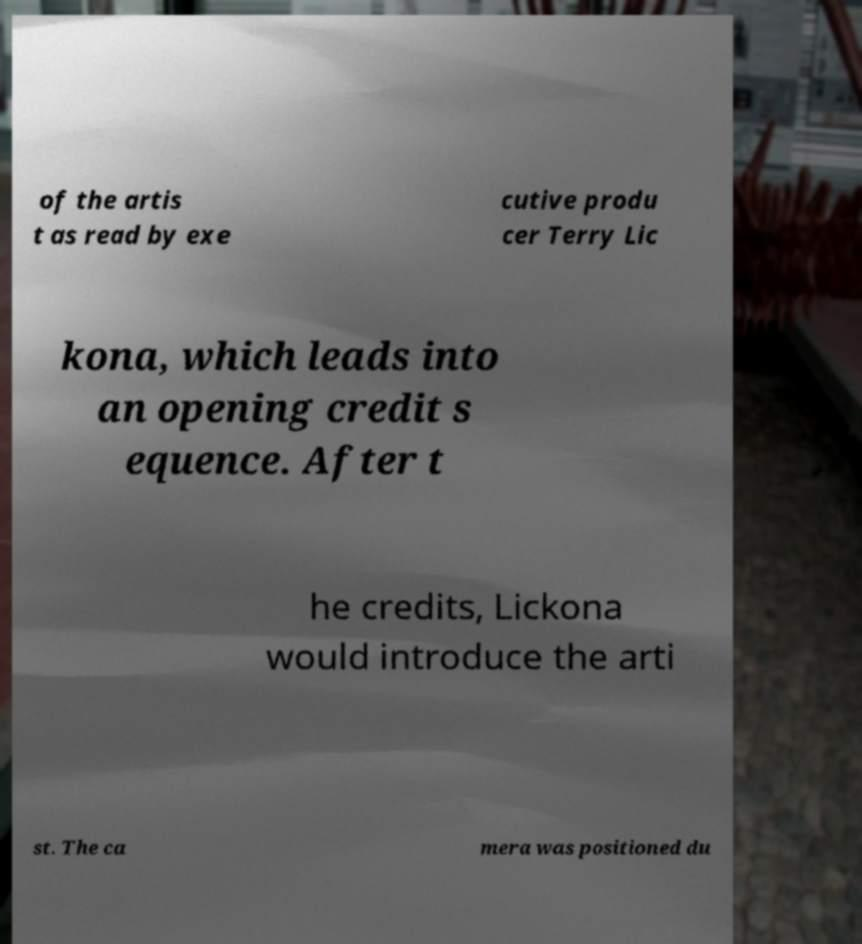Please identify and transcribe the text found in this image. of the artis t as read by exe cutive produ cer Terry Lic kona, which leads into an opening credit s equence. After t he credits, Lickona would introduce the arti st. The ca mera was positioned du 